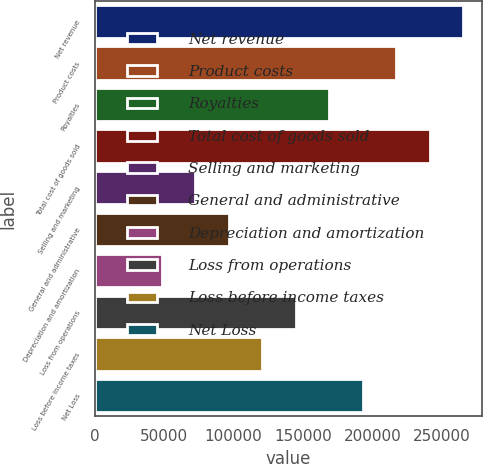<chart> <loc_0><loc_0><loc_500><loc_500><bar_chart><fcel>Net revenue<fcel>Product costs<fcel>Royalties<fcel>Total cost of goods sold<fcel>Selling and marketing<fcel>General and administrative<fcel>Depreciation and amortization<fcel>Loss from operations<fcel>Loss before income taxes<fcel>Net Loss<nl><fcel>265299<fcel>217063<fcel>168827<fcel>241181<fcel>72355.2<fcel>96473.2<fcel>48237.2<fcel>144709<fcel>120591<fcel>192945<nl></chart> 